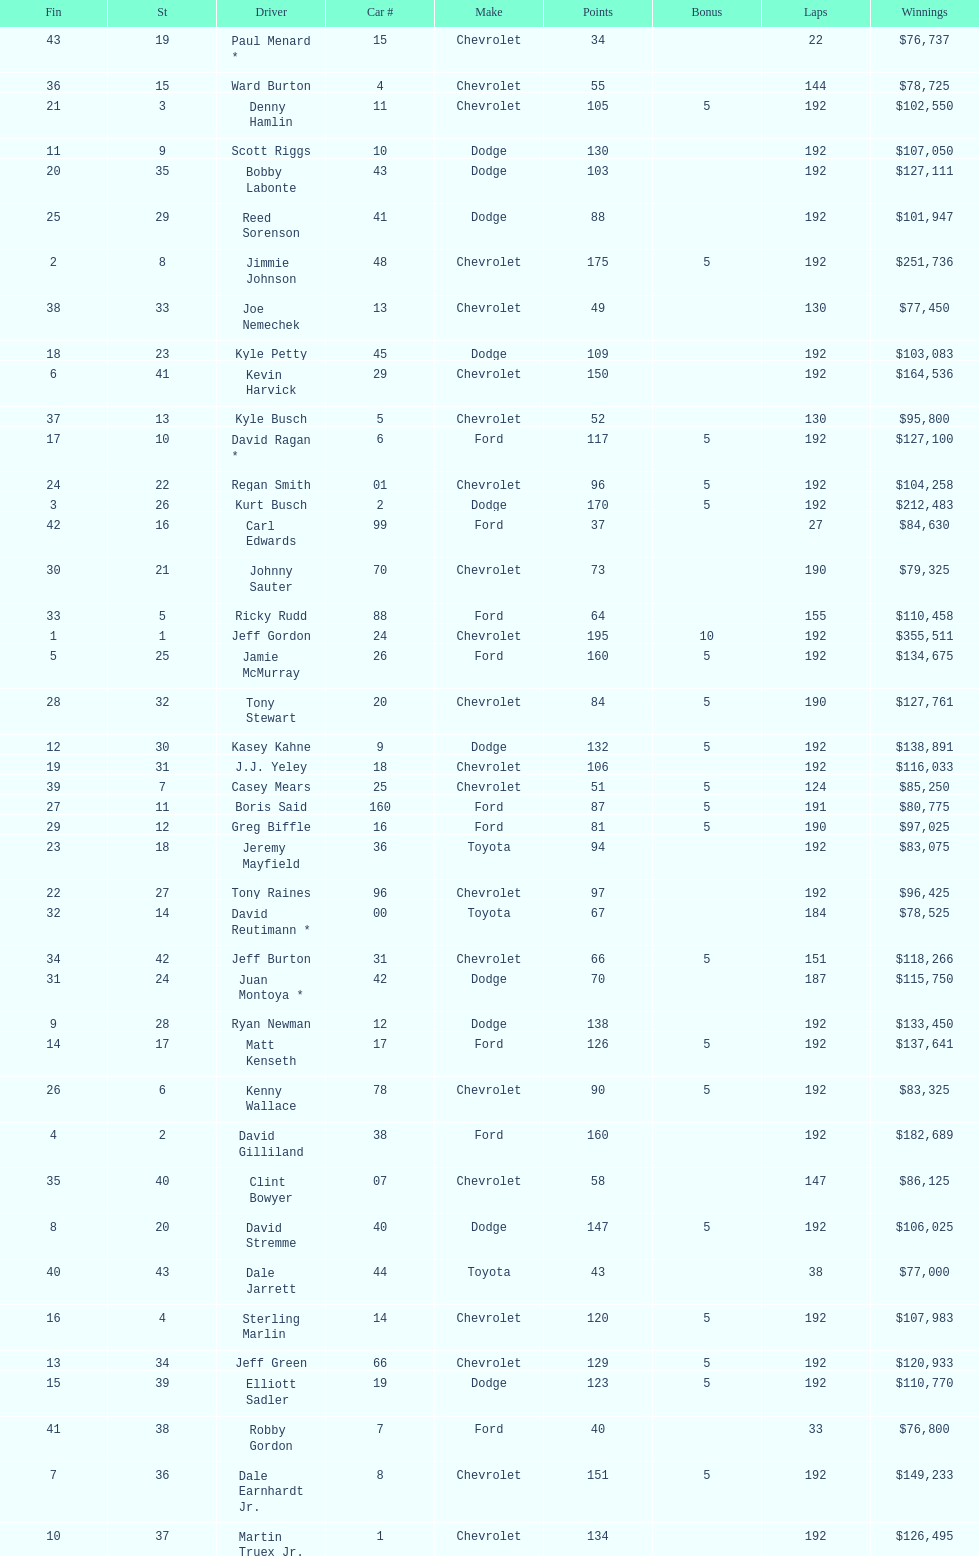How many drivers placed below tony stewart? 15. 